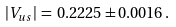Convert formula to latex. <formula><loc_0><loc_0><loc_500><loc_500>| V _ { u s } | \, = \, 0 . 2 2 2 5 \pm 0 . 0 0 1 6 \, .</formula> 